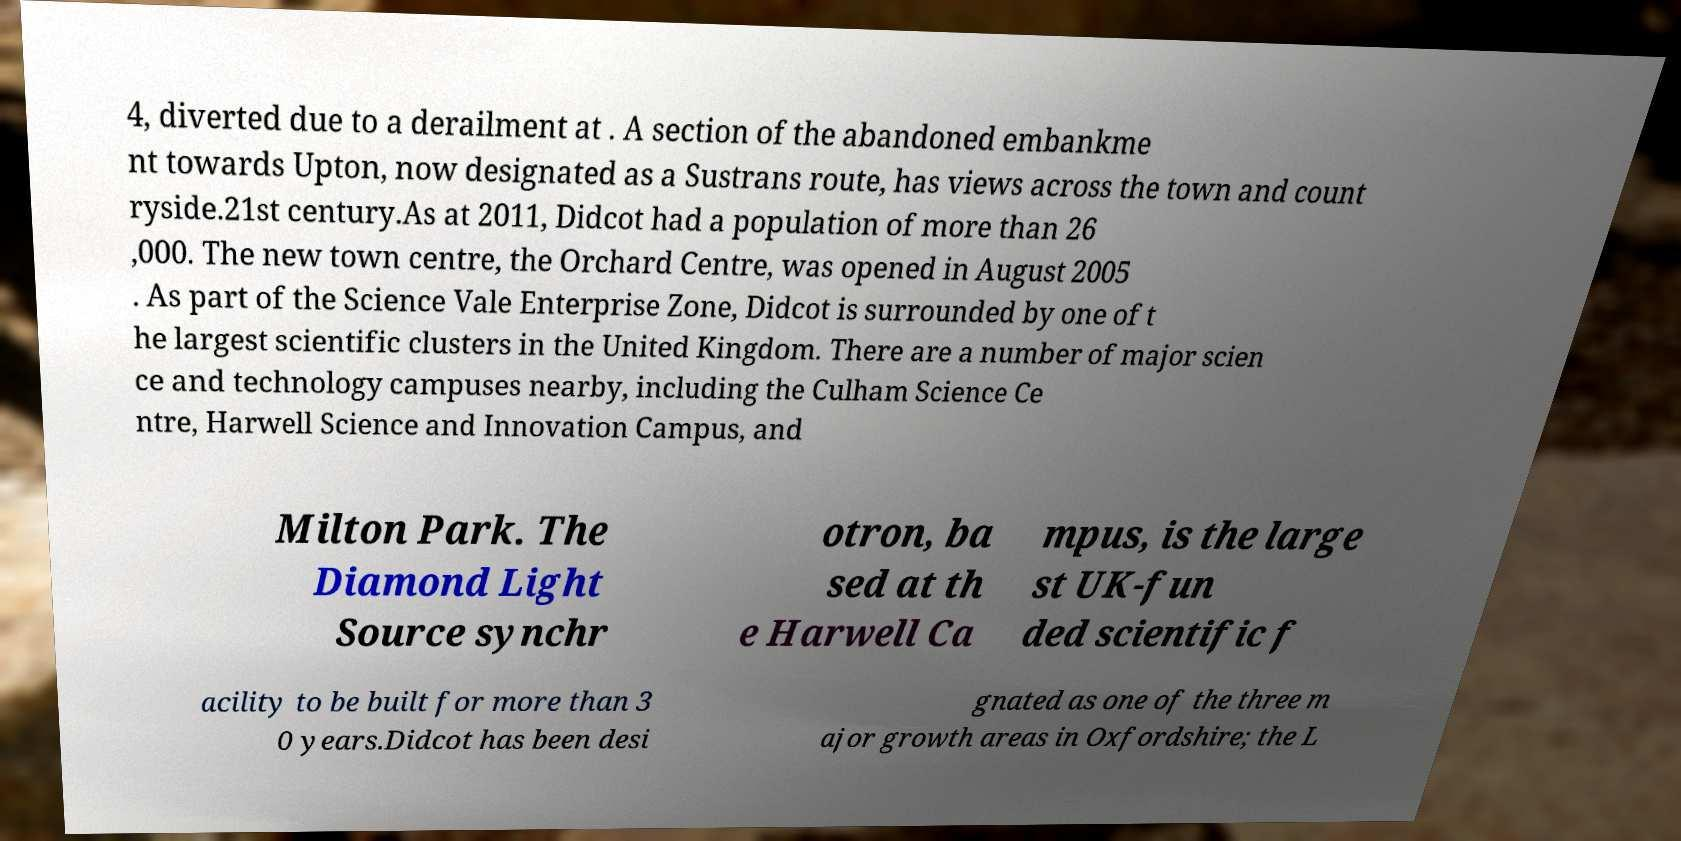For documentation purposes, I need the text within this image transcribed. Could you provide that? 4, diverted due to a derailment at . A section of the abandoned embankme nt towards Upton, now designated as a Sustrans route, has views across the town and count ryside.21st century.As at 2011, Didcot had a population of more than 26 ,000. The new town centre, the Orchard Centre, was opened in August 2005 . As part of the Science Vale Enterprise Zone, Didcot is surrounded by one of t he largest scientific clusters in the United Kingdom. There are a number of major scien ce and technology campuses nearby, including the Culham Science Ce ntre, Harwell Science and Innovation Campus, and Milton Park. The Diamond Light Source synchr otron, ba sed at th e Harwell Ca mpus, is the large st UK-fun ded scientific f acility to be built for more than 3 0 years.Didcot has been desi gnated as one of the three m ajor growth areas in Oxfordshire; the L 